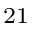Convert formula to latex. <formula><loc_0><loc_0><loc_500><loc_500>^ { 2 1 }</formula> 